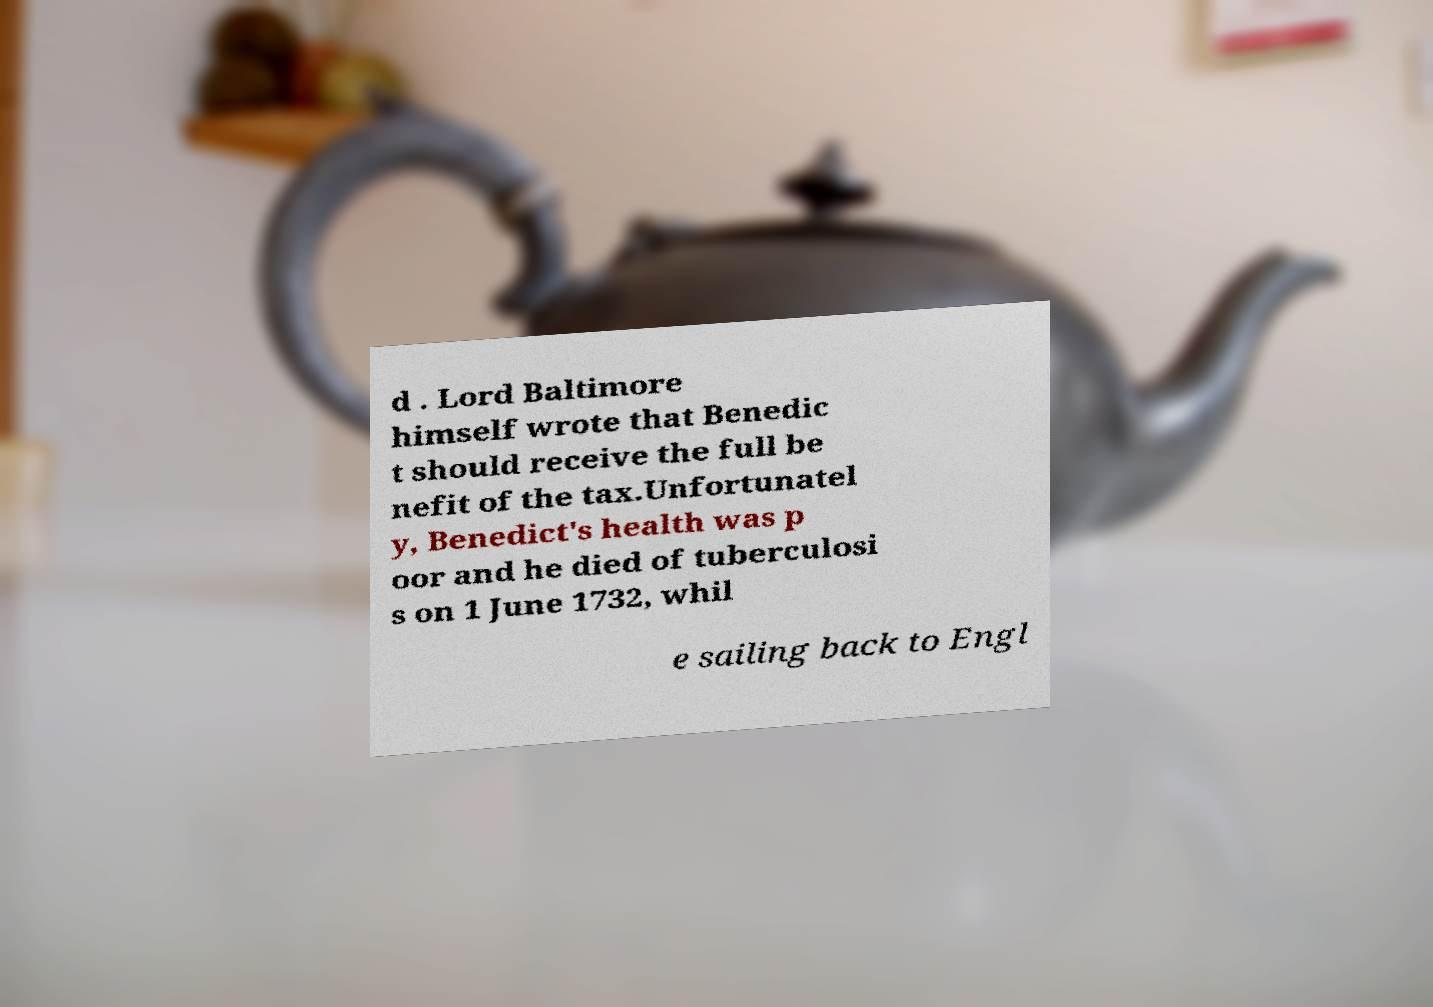Can you read and provide the text displayed in the image?This photo seems to have some interesting text. Can you extract and type it out for me? d . Lord Baltimore himself wrote that Benedic t should receive the full be nefit of the tax.Unfortunatel y, Benedict's health was p oor and he died of tuberculosi s on 1 June 1732, whil e sailing back to Engl 